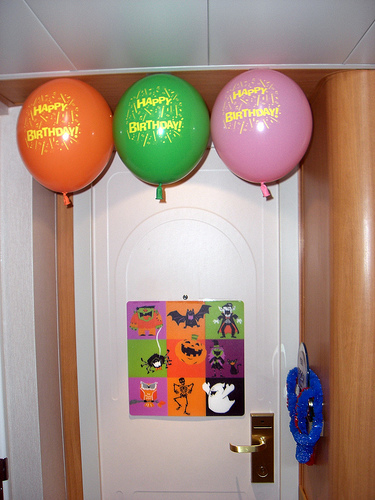<image>
Can you confirm if the green baloon is to the left of the pink baloon? Yes. From this viewpoint, the green baloon is positioned to the left side relative to the pink baloon. 